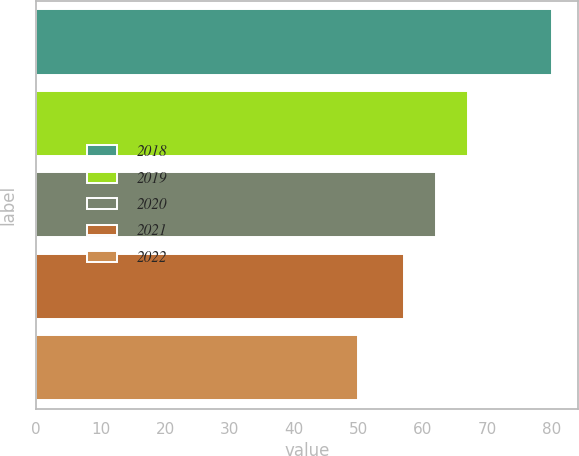<chart> <loc_0><loc_0><loc_500><loc_500><bar_chart><fcel>2018<fcel>2019<fcel>2020<fcel>2021<fcel>2022<nl><fcel>80<fcel>67<fcel>62<fcel>57<fcel>50<nl></chart> 